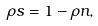Convert formula to latex. <formula><loc_0><loc_0><loc_500><loc_500>\rho s = 1 - \rho n ,</formula> 